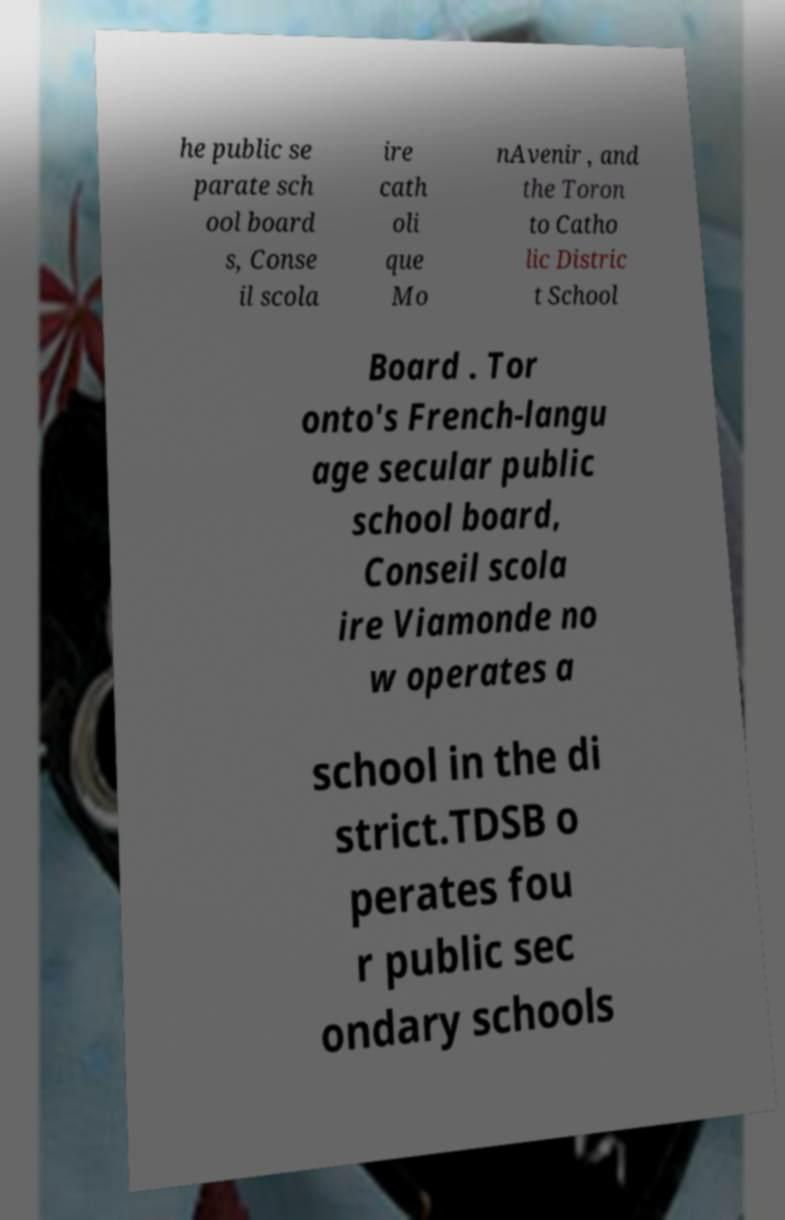Could you extract and type out the text from this image? he public se parate sch ool board s, Conse il scola ire cath oli que Mo nAvenir , and the Toron to Catho lic Distric t School Board . Tor onto's French-langu age secular public school board, Conseil scola ire Viamonde no w operates a school in the di strict.TDSB o perates fou r public sec ondary schools 